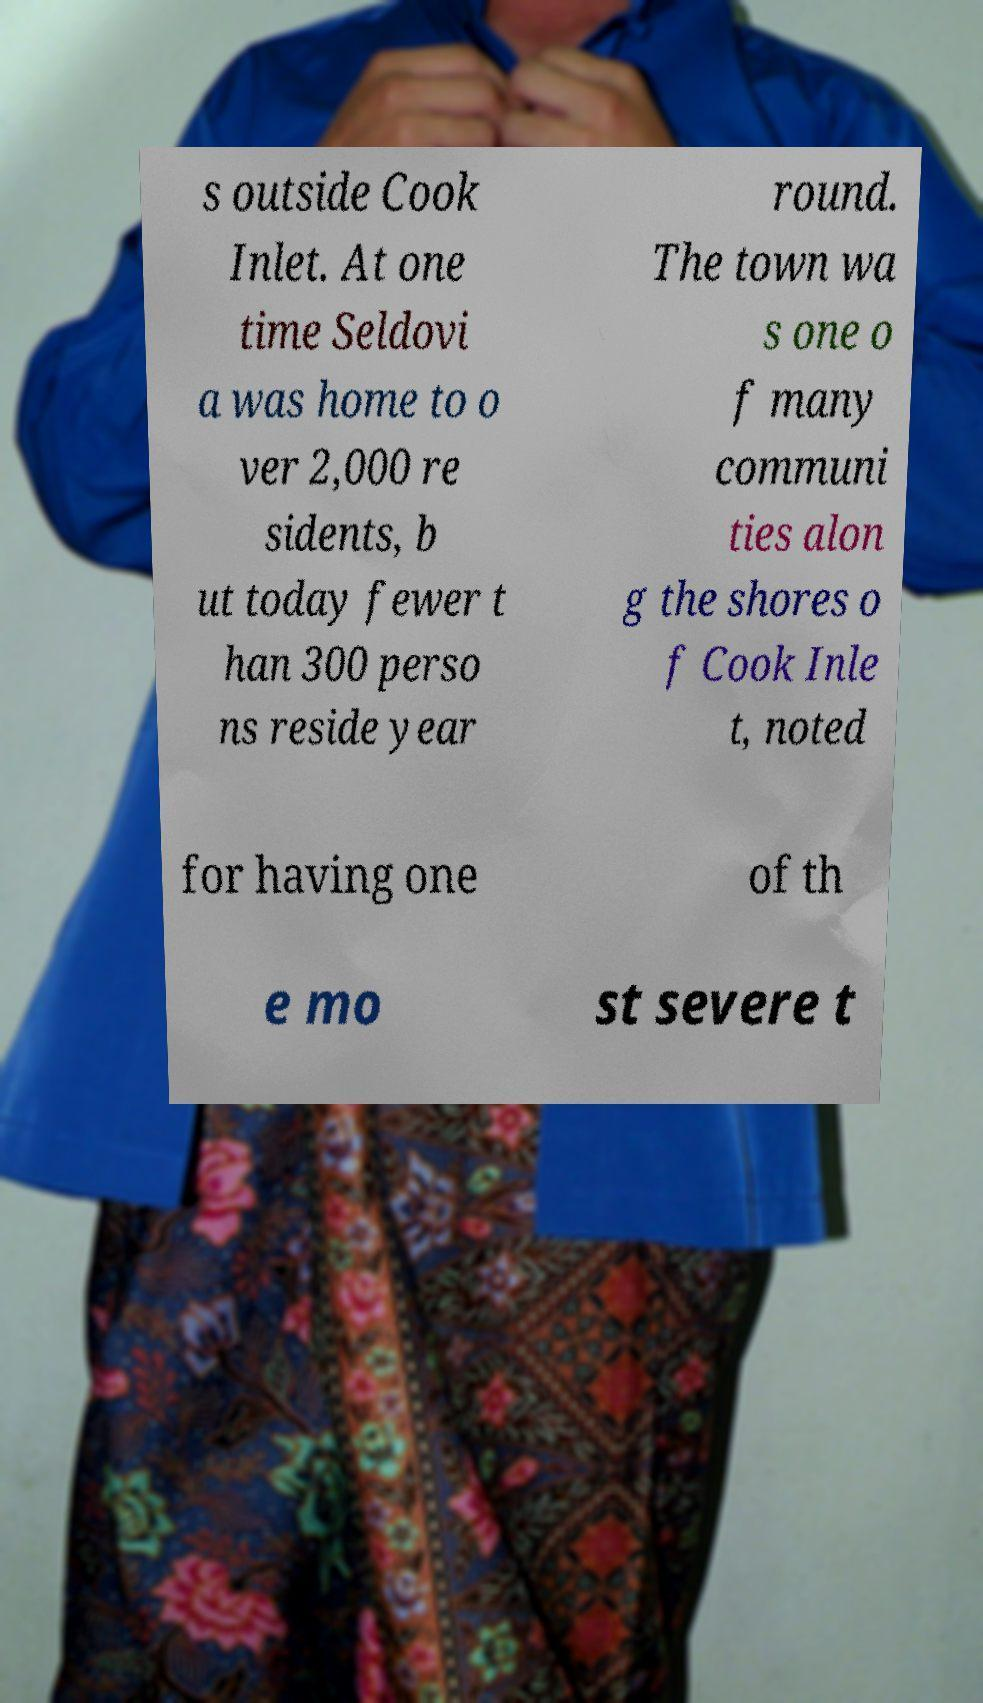Please identify and transcribe the text found in this image. s outside Cook Inlet. At one time Seldovi a was home to o ver 2,000 re sidents, b ut today fewer t han 300 perso ns reside year round. The town wa s one o f many communi ties alon g the shores o f Cook Inle t, noted for having one of th e mo st severe t 